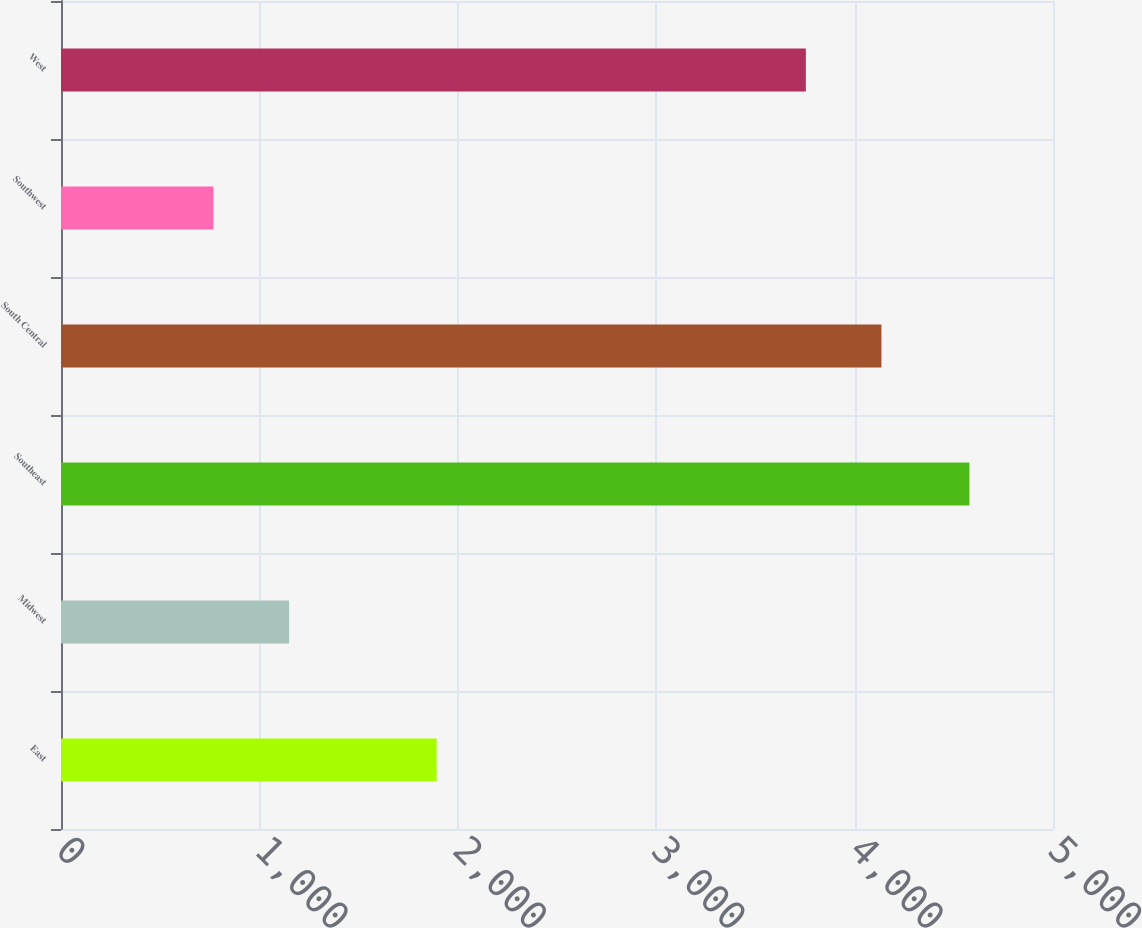Convert chart to OTSL. <chart><loc_0><loc_0><loc_500><loc_500><bar_chart><fcel>East<fcel>Midwest<fcel>Southeast<fcel>South Central<fcel>Southwest<fcel>West<nl><fcel>1893.4<fcel>1149.69<fcel>4578.6<fcel>4135.29<fcel>768.7<fcel>3754.3<nl></chart> 